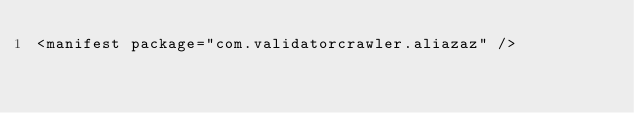<code> <loc_0><loc_0><loc_500><loc_500><_XML_><manifest package="com.validatorcrawler.aliazaz" />
</code> 